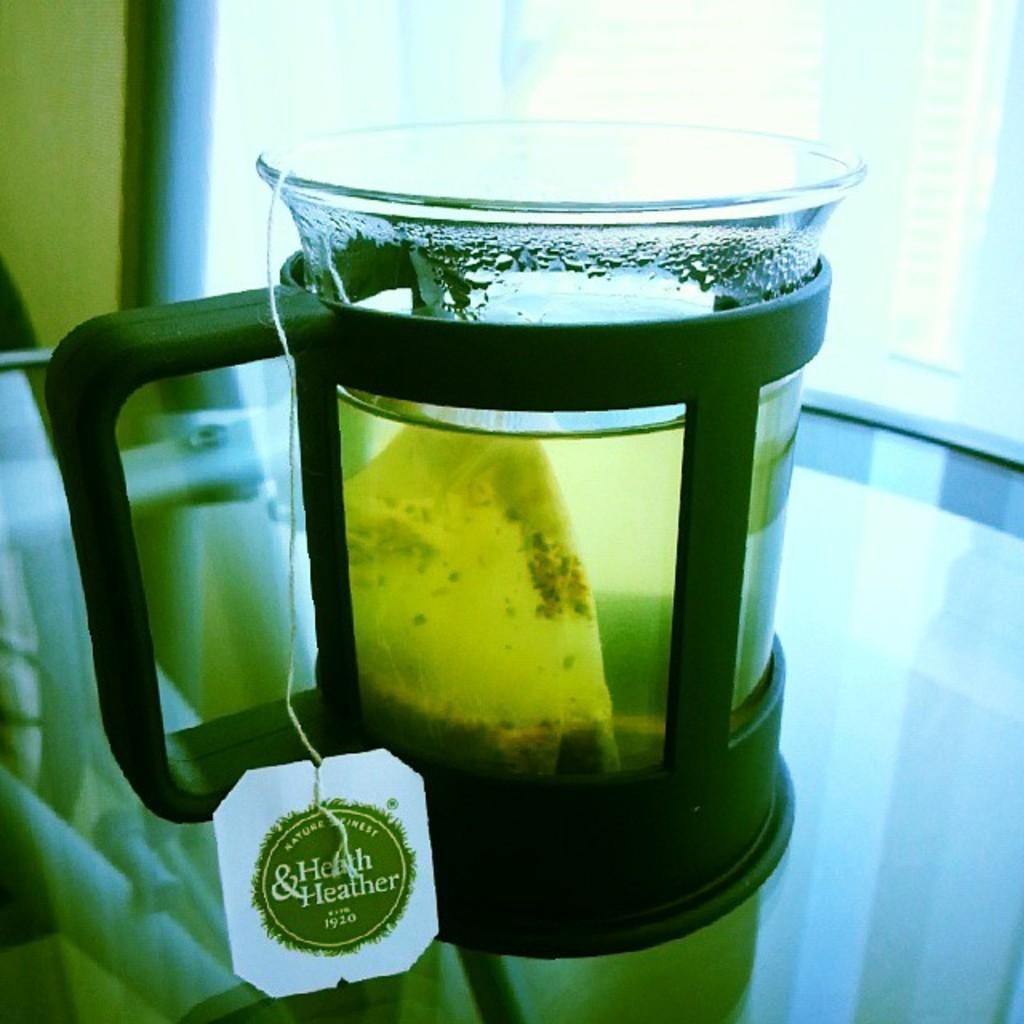Please provide a concise description of this image. In this image there is a tea in the glass jar which is placed on the table. In the background of the image there is a glass window. 